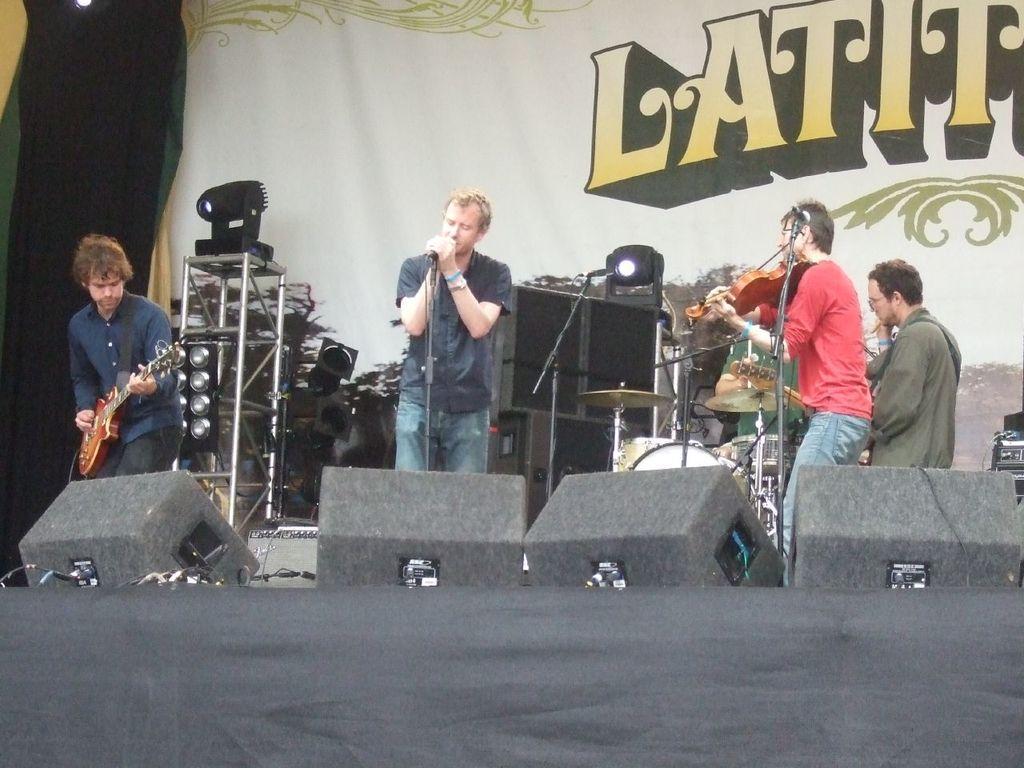How would you summarize this image in a sentence or two? In the foreground of this image, there is a black color cloth and few lights on the stage. In the background, there are persons playing musical instruments and a man holding mic and there are mics in front of them. In the background, there is a banner, curtain, lights and the speaker boxes. 